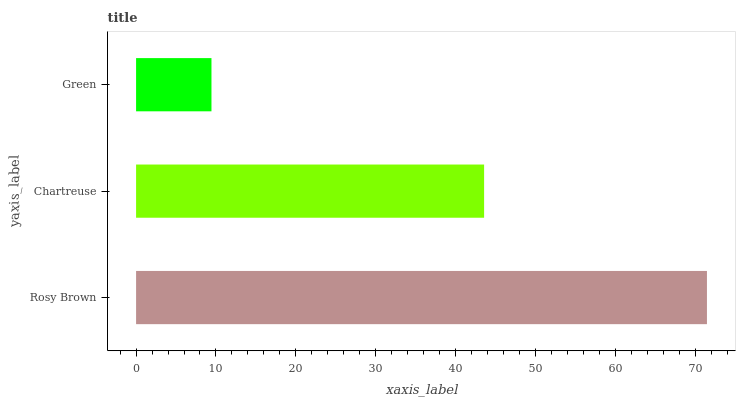Is Green the minimum?
Answer yes or no. Yes. Is Rosy Brown the maximum?
Answer yes or no. Yes. Is Chartreuse the minimum?
Answer yes or no. No. Is Chartreuse the maximum?
Answer yes or no. No. Is Rosy Brown greater than Chartreuse?
Answer yes or no. Yes. Is Chartreuse less than Rosy Brown?
Answer yes or no. Yes. Is Chartreuse greater than Rosy Brown?
Answer yes or no. No. Is Rosy Brown less than Chartreuse?
Answer yes or no. No. Is Chartreuse the high median?
Answer yes or no. Yes. Is Chartreuse the low median?
Answer yes or no. Yes. Is Rosy Brown the high median?
Answer yes or no. No. Is Green the low median?
Answer yes or no. No. 